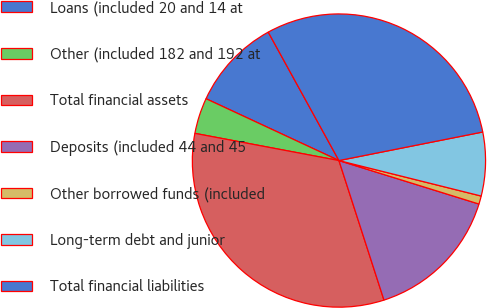<chart> <loc_0><loc_0><loc_500><loc_500><pie_chart><fcel>Loans (included 20 and 14 at<fcel>Other (included 182 and 192 at<fcel>Total financial assets<fcel>Deposits (included 44 and 45<fcel>Other borrowed funds (included<fcel>Long-term debt and junior<fcel>Total financial liabilities<nl><fcel>10.06%<fcel>3.96%<fcel>32.94%<fcel>15.24%<fcel>0.9%<fcel>7.01%<fcel>29.89%<nl></chart> 